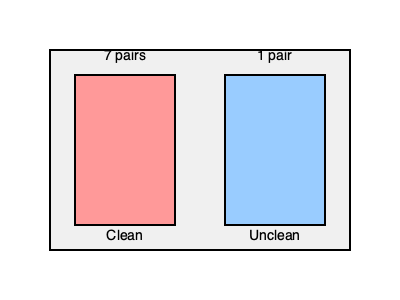According to Genesis 7:2-3, God instructed Noah to take seven pairs of clean animals and one pair of unclean animals into the ark. Based on this information and the diagram, what is the ratio of clean animals to unclean animals on the ark? To determine the ratio of clean animals to unclean animals, we need to follow these steps:

1. Understand the given information:
   - Clean animals: 7 pairs
   - Unclean animals: 1 pair

2. Calculate the total number of clean animals:
   $7 \text{ pairs} \times 2 \text{ animals per pair} = 14 \text{ clean animals}$

3. Calculate the total number of unclean animals:
   $1 \text{ pair} \times 2 \text{ animals per pair} = 2 \text{ unclean animals}$

4. Express the ratio of clean to unclean animals:
   $14 \text{ clean} : 2 \text{ unclean}$

5. Simplify the ratio by dividing both sides by their greatest common factor (2):
   $\frac{14}{2} : \frac{2}{2} = 7 : 1$

Therefore, the simplified ratio of clean animals to unclean animals on Noah's Ark is 7:1.
Answer: 7:1 